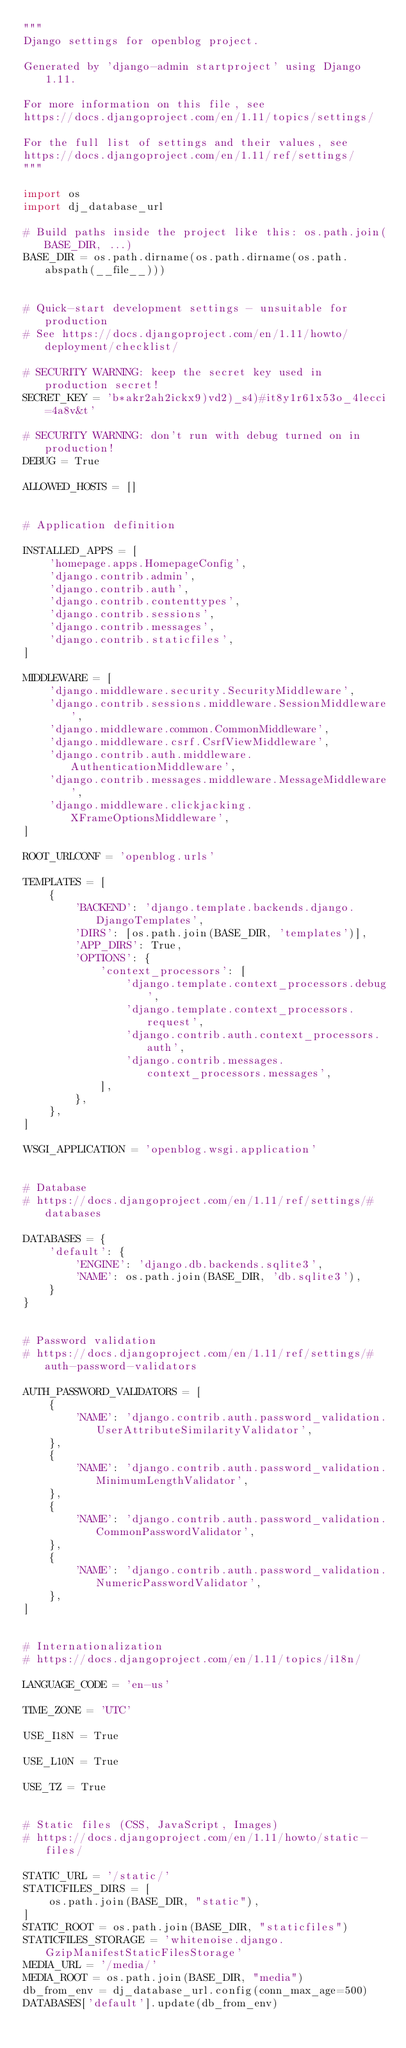Convert code to text. <code><loc_0><loc_0><loc_500><loc_500><_Python_>"""
Django settings for openblog project.

Generated by 'django-admin startproject' using Django 1.11.

For more information on this file, see
https://docs.djangoproject.com/en/1.11/topics/settings/

For the full list of settings and their values, see
https://docs.djangoproject.com/en/1.11/ref/settings/
"""

import os
import dj_database_url

# Build paths inside the project like this: os.path.join(BASE_DIR, ...)
BASE_DIR = os.path.dirname(os.path.dirname(os.path.abspath(__file__)))


# Quick-start development settings - unsuitable for production
# See https://docs.djangoproject.com/en/1.11/howto/deployment/checklist/

# SECURITY WARNING: keep the secret key used in production secret!
SECRET_KEY = 'b*akr2ah2ickx9)vd2)_s4)#it8y1r61x53o_4lecci=4a8v&t'

# SECURITY WARNING: don't run with debug turned on in production!
DEBUG = True

ALLOWED_HOSTS = []


# Application definition

INSTALLED_APPS = [
    'homepage.apps.HomepageConfig',
    'django.contrib.admin',
    'django.contrib.auth',
    'django.contrib.contenttypes',
    'django.contrib.sessions',
    'django.contrib.messages',
    'django.contrib.staticfiles',
]

MIDDLEWARE = [
    'django.middleware.security.SecurityMiddleware',
    'django.contrib.sessions.middleware.SessionMiddleware',
    'django.middleware.common.CommonMiddleware',
    'django.middleware.csrf.CsrfViewMiddleware',
    'django.contrib.auth.middleware.AuthenticationMiddleware',
    'django.contrib.messages.middleware.MessageMiddleware',
    'django.middleware.clickjacking.XFrameOptionsMiddleware',
]

ROOT_URLCONF = 'openblog.urls'

TEMPLATES = [
    {
        'BACKEND': 'django.template.backends.django.DjangoTemplates',
        'DIRS': [os.path.join(BASE_DIR, 'templates')],
        'APP_DIRS': True,
        'OPTIONS': {
            'context_processors': [
                'django.template.context_processors.debug',
                'django.template.context_processors.request',
                'django.contrib.auth.context_processors.auth',
                'django.contrib.messages.context_processors.messages',
            ],
        },
    },
]

WSGI_APPLICATION = 'openblog.wsgi.application'


# Database
# https://docs.djangoproject.com/en/1.11/ref/settings/#databases

DATABASES = {
    'default': {
        'ENGINE': 'django.db.backends.sqlite3',
        'NAME': os.path.join(BASE_DIR, 'db.sqlite3'),
    }
}


# Password validation
# https://docs.djangoproject.com/en/1.11/ref/settings/#auth-password-validators

AUTH_PASSWORD_VALIDATORS = [
    {
        'NAME': 'django.contrib.auth.password_validation.UserAttributeSimilarityValidator',
    },
    {
        'NAME': 'django.contrib.auth.password_validation.MinimumLengthValidator',
    },
    {
        'NAME': 'django.contrib.auth.password_validation.CommonPasswordValidator',
    },
    {
        'NAME': 'django.contrib.auth.password_validation.NumericPasswordValidator',
    },
]


# Internationalization
# https://docs.djangoproject.com/en/1.11/topics/i18n/

LANGUAGE_CODE = 'en-us'

TIME_ZONE = 'UTC'

USE_I18N = True

USE_L10N = True

USE_TZ = True


# Static files (CSS, JavaScript, Images)
# https://docs.djangoproject.com/en/1.11/howto/static-files/

STATIC_URL = '/static/'
STATICFILES_DIRS = [
    os.path.join(BASE_DIR, "static"),
]
STATIC_ROOT = os.path.join(BASE_DIR, "staticfiles")
STATICFILES_STORAGE = 'whitenoise.django.GzipManifestStaticFilesStorage'
MEDIA_URL = '/media/'
MEDIA_ROOT = os.path.join(BASE_DIR, "media")
db_from_env = dj_database_url.config(conn_max_age=500)
DATABASES['default'].update(db_from_env)
</code> 